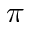Convert formula to latex. <formula><loc_0><loc_0><loc_500><loc_500>\pi</formula> 